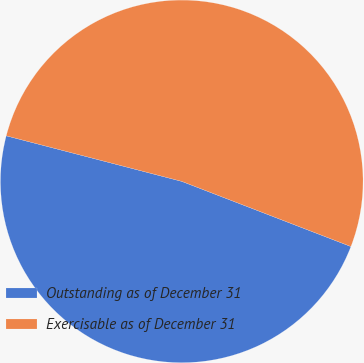Convert chart. <chart><loc_0><loc_0><loc_500><loc_500><pie_chart><fcel>Outstanding as of December 31<fcel>Exercisable as of December 31<nl><fcel>48.19%<fcel>51.81%<nl></chart> 